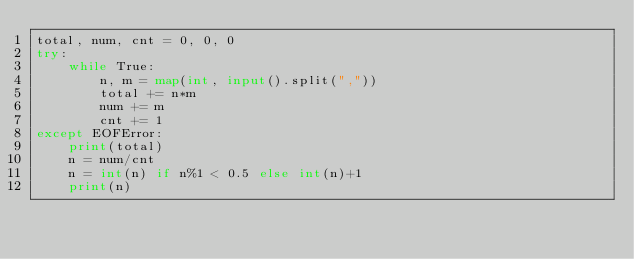Convert code to text. <code><loc_0><loc_0><loc_500><loc_500><_Python_>total, num, cnt = 0, 0, 0
try:
    while True:
        n, m = map(int, input().split(","))
        total += n*m
        num += m
        cnt += 1
except EOFError:
    print(total)
    n = num/cnt
    n = int(n) if n%1 < 0.5 else int(n)+1
    print(n)
</code> 